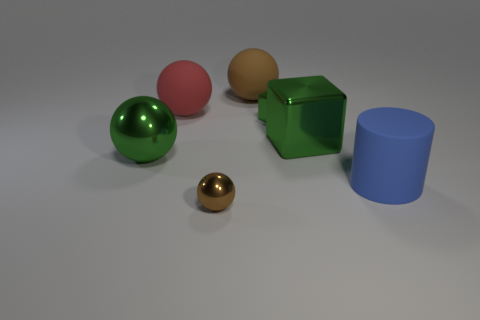Imagine these objects are part of a children's game. How might they be used in gameplay? In a hypothetical children's game, these objects could serve various purposes. The spheres could be used as balls to roll to specific targets or into holes, while the cube and cylinder might serve as blocks for stacking or as obstacles to navigate around. The metallic textures may signify special game elements, like bonus items, that offer extra points or advantages when collected. 